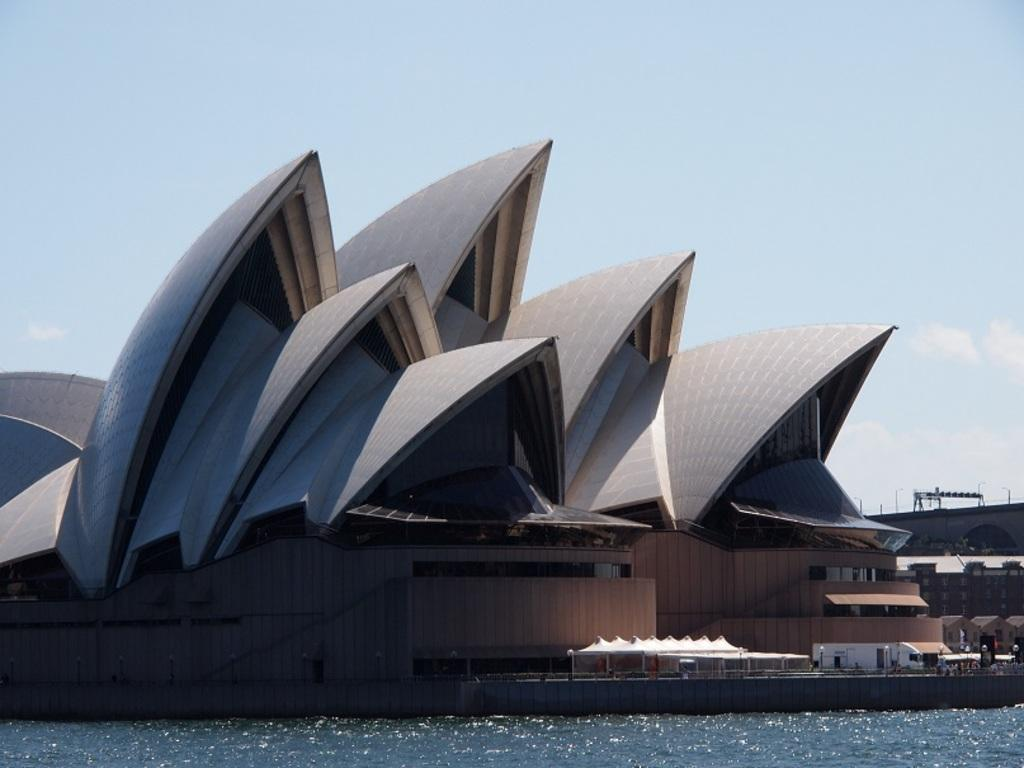What type of structure is visible in the image? There is a building in the image. What natural feature is located in front of the building? There is a lake in front of the building. What is visible at the top of the image? The sky is visible at the top of the image. What type of approval does the carpenter need to work on the building in the image? There is no carpenter present in the image, and therefore no need for approval. What role does the stem play in the image? There is no stem present in the image. 